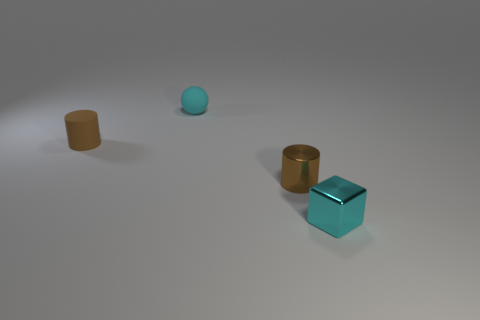There is a brown thing that is on the right side of the cyan matte object behind the metal cube in front of the cyan rubber thing; what size is it?
Keep it short and to the point. Small. There is a cylinder to the right of the tiny cyan ball; what color is it?
Make the answer very short. Brown. The small matte thing that is the same color as the small cube is what shape?
Your response must be concise. Sphere. There is a brown thing that is in front of the brown rubber cylinder; what is its shape?
Offer a very short reply. Cylinder. How many green objects are either rubber balls or tiny things?
Offer a terse response. 0. How many tiny cylinders are right of the small brown rubber cylinder?
Ensure brevity in your answer.  1. There is a small object that is to the right of the small matte cylinder and to the left of the brown metallic cylinder; what material is it?
Ensure brevity in your answer.  Rubber. How many cylinders are big purple things or small brown metallic things?
Provide a short and direct response. 1. There is another brown thing that is the same shape as the small brown metal object; what is it made of?
Provide a succinct answer. Rubber. The brown cylinder that is made of the same material as the sphere is what size?
Ensure brevity in your answer.  Small. 